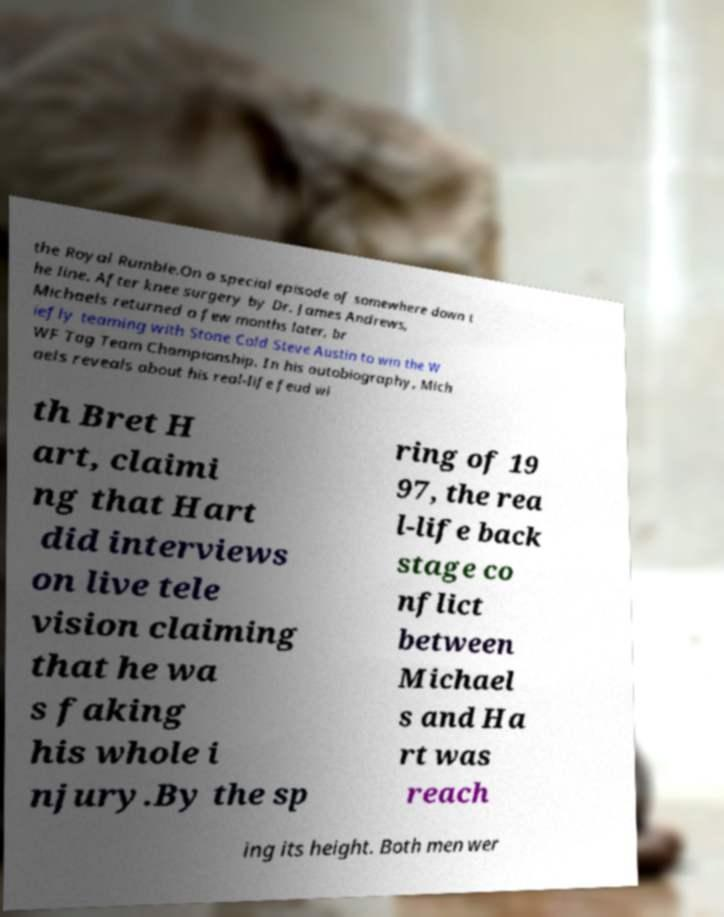Can you read and provide the text displayed in the image?This photo seems to have some interesting text. Can you extract and type it out for me? the Royal Rumble.On a special episode of somewhere down t he line. After knee surgery by Dr. James Andrews, Michaels returned a few months later, br iefly teaming with Stone Cold Steve Austin to win the W WF Tag Team Championship. In his autobiography, Mich aels reveals about his real-life feud wi th Bret H art, claimi ng that Hart did interviews on live tele vision claiming that he wa s faking his whole i njury.By the sp ring of 19 97, the rea l-life back stage co nflict between Michael s and Ha rt was reach ing its height. Both men wer 